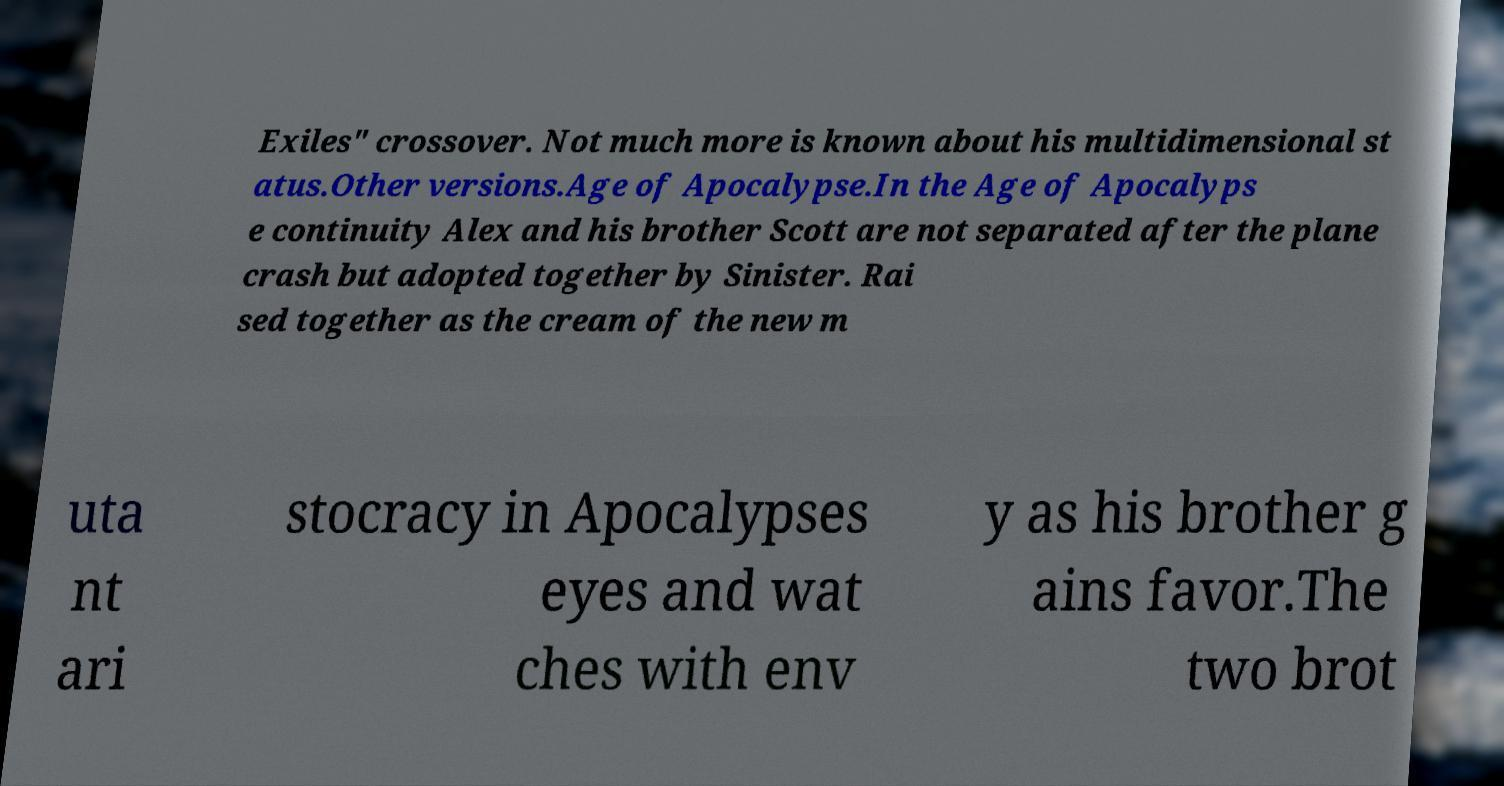Could you assist in decoding the text presented in this image and type it out clearly? Exiles" crossover. Not much more is known about his multidimensional st atus.Other versions.Age of Apocalypse.In the Age of Apocalyps e continuity Alex and his brother Scott are not separated after the plane crash but adopted together by Sinister. Rai sed together as the cream of the new m uta nt ari stocracy in Apocalypses eyes and wat ches with env y as his brother g ains favor.The two brot 